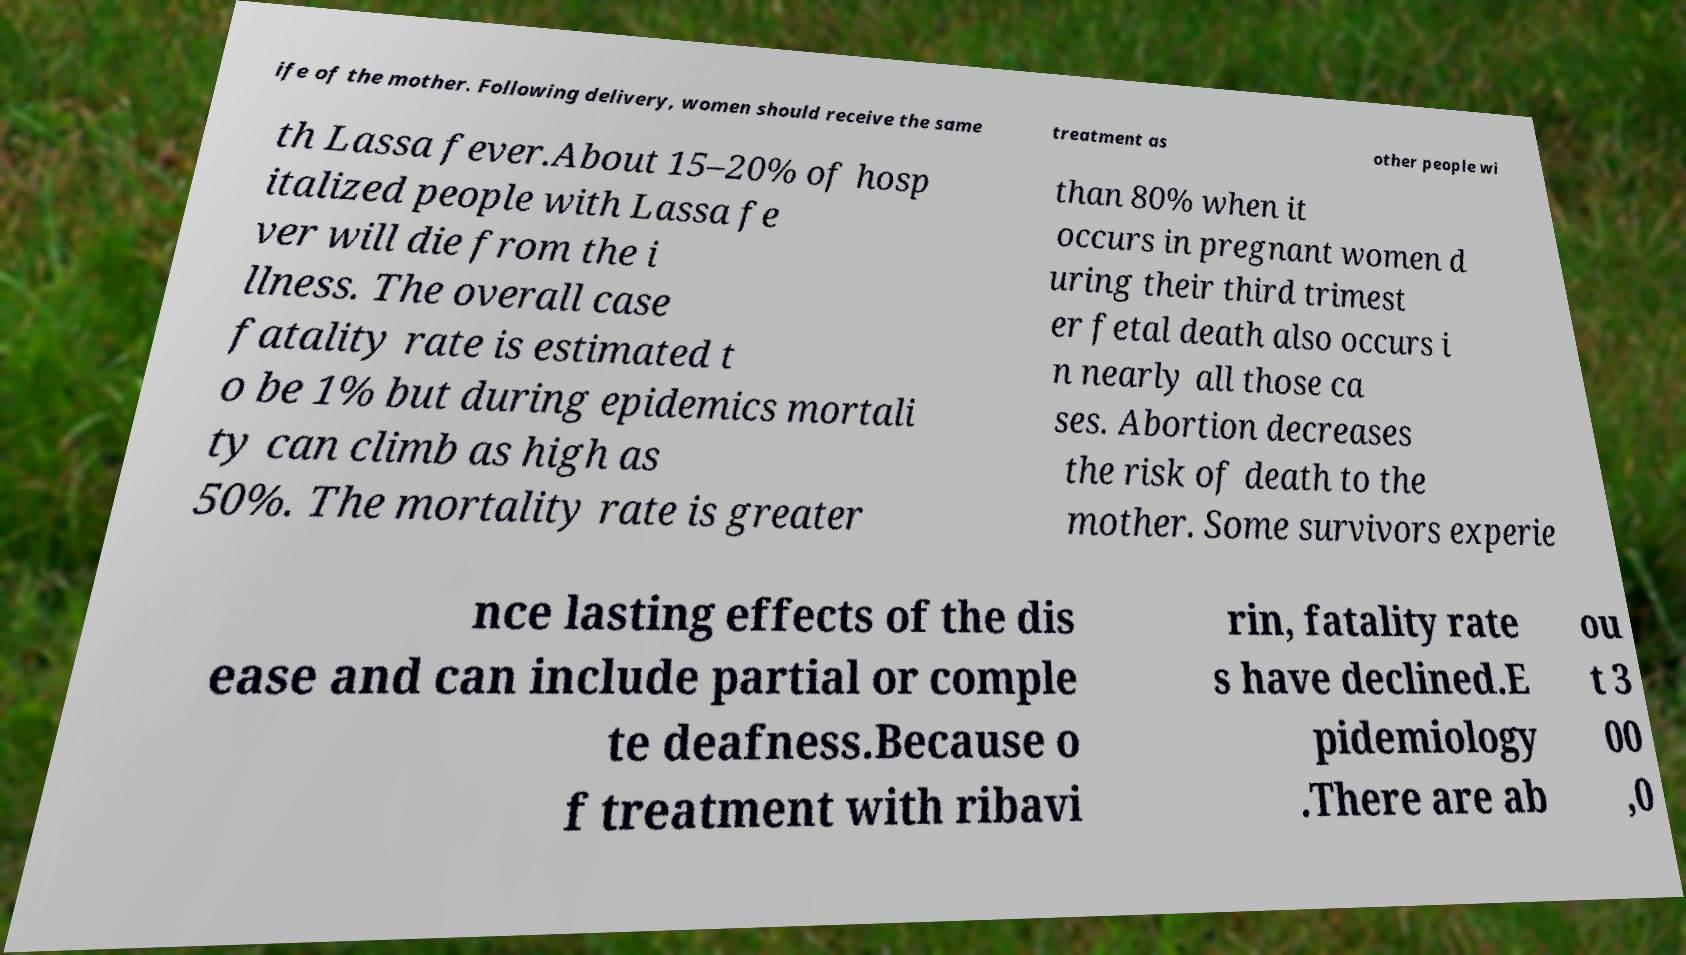Could you assist in decoding the text presented in this image and type it out clearly? ife of the mother. Following delivery, women should receive the same treatment as other people wi th Lassa fever.About 15–20% of hosp italized people with Lassa fe ver will die from the i llness. The overall case fatality rate is estimated t o be 1% but during epidemics mortali ty can climb as high as 50%. The mortality rate is greater than 80% when it occurs in pregnant women d uring their third trimest er fetal death also occurs i n nearly all those ca ses. Abortion decreases the risk of death to the mother. Some survivors experie nce lasting effects of the dis ease and can include partial or comple te deafness.Because o f treatment with ribavi rin, fatality rate s have declined.E pidemiology .There are ab ou t 3 00 ,0 